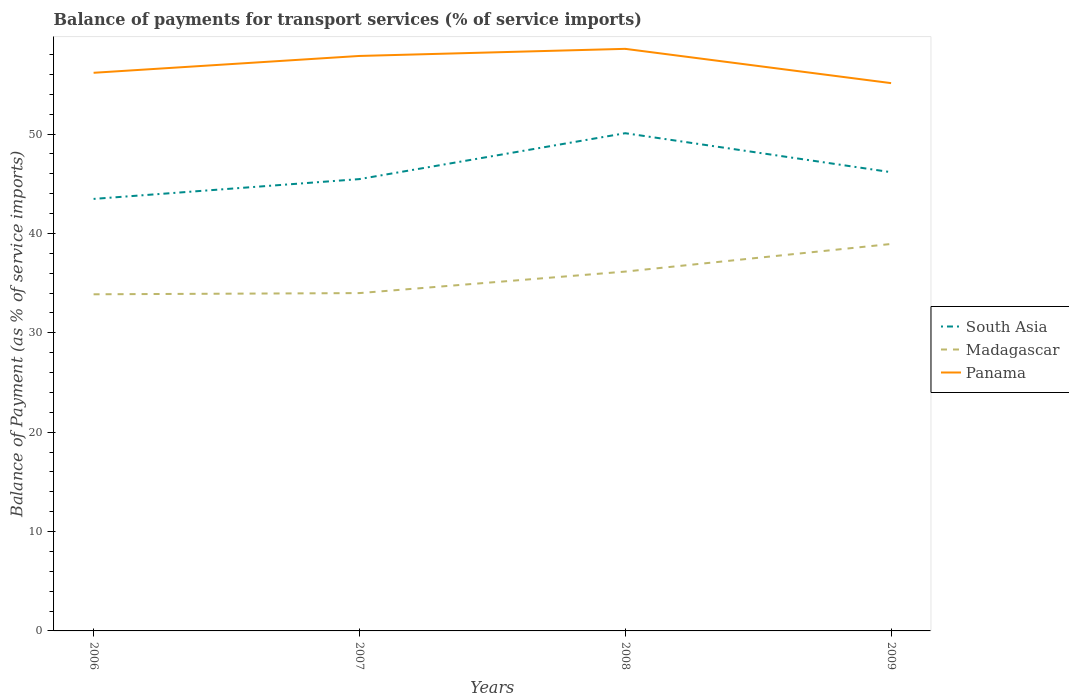Across all years, what is the maximum balance of payments for transport services in Panama?
Your response must be concise. 55.13. In which year was the balance of payments for transport services in Panama maximum?
Provide a short and direct response. 2009. What is the total balance of payments for transport services in Panama in the graph?
Provide a succinct answer. -0.71. What is the difference between the highest and the second highest balance of payments for transport services in Panama?
Your answer should be very brief. 3.45. What is the difference between the highest and the lowest balance of payments for transport services in Panama?
Provide a short and direct response. 2. Is the balance of payments for transport services in South Asia strictly greater than the balance of payments for transport services in Madagascar over the years?
Your response must be concise. No. How many lines are there?
Your answer should be very brief. 3. How many years are there in the graph?
Your response must be concise. 4. Are the values on the major ticks of Y-axis written in scientific E-notation?
Give a very brief answer. No. Does the graph contain grids?
Your answer should be compact. No. How are the legend labels stacked?
Provide a short and direct response. Vertical. What is the title of the graph?
Provide a short and direct response. Balance of payments for transport services (% of service imports). What is the label or title of the Y-axis?
Provide a succinct answer. Balance of Payment (as % of service imports). What is the Balance of Payment (as % of service imports) in South Asia in 2006?
Give a very brief answer. 43.48. What is the Balance of Payment (as % of service imports) in Madagascar in 2006?
Offer a terse response. 33.88. What is the Balance of Payment (as % of service imports) of Panama in 2006?
Your answer should be very brief. 56.17. What is the Balance of Payment (as % of service imports) in South Asia in 2007?
Your answer should be compact. 45.47. What is the Balance of Payment (as % of service imports) of Madagascar in 2007?
Give a very brief answer. 34. What is the Balance of Payment (as % of service imports) in Panama in 2007?
Offer a terse response. 57.86. What is the Balance of Payment (as % of service imports) of South Asia in 2008?
Offer a very short reply. 50.09. What is the Balance of Payment (as % of service imports) of Madagascar in 2008?
Ensure brevity in your answer.  36.16. What is the Balance of Payment (as % of service imports) in Panama in 2008?
Offer a very short reply. 58.58. What is the Balance of Payment (as % of service imports) of South Asia in 2009?
Keep it short and to the point. 46.17. What is the Balance of Payment (as % of service imports) of Madagascar in 2009?
Provide a short and direct response. 38.94. What is the Balance of Payment (as % of service imports) in Panama in 2009?
Provide a succinct answer. 55.13. Across all years, what is the maximum Balance of Payment (as % of service imports) in South Asia?
Make the answer very short. 50.09. Across all years, what is the maximum Balance of Payment (as % of service imports) in Madagascar?
Give a very brief answer. 38.94. Across all years, what is the maximum Balance of Payment (as % of service imports) of Panama?
Give a very brief answer. 58.58. Across all years, what is the minimum Balance of Payment (as % of service imports) of South Asia?
Provide a succinct answer. 43.48. Across all years, what is the minimum Balance of Payment (as % of service imports) of Madagascar?
Your answer should be compact. 33.88. Across all years, what is the minimum Balance of Payment (as % of service imports) of Panama?
Your answer should be very brief. 55.13. What is the total Balance of Payment (as % of service imports) of South Asia in the graph?
Make the answer very short. 185.2. What is the total Balance of Payment (as % of service imports) in Madagascar in the graph?
Give a very brief answer. 142.98. What is the total Balance of Payment (as % of service imports) of Panama in the graph?
Offer a very short reply. 227.74. What is the difference between the Balance of Payment (as % of service imports) in South Asia in 2006 and that in 2007?
Keep it short and to the point. -2. What is the difference between the Balance of Payment (as % of service imports) in Madagascar in 2006 and that in 2007?
Give a very brief answer. -0.12. What is the difference between the Balance of Payment (as % of service imports) in Panama in 2006 and that in 2007?
Provide a short and direct response. -1.7. What is the difference between the Balance of Payment (as % of service imports) of South Asia in 2006 and that in 2008?
Your answer should be very brief. -6.61. What is the difference between the Balance of Payment (as % of service imports) of Madagascar in 2006 and that in 2008?
Your response must be concise. -2.28. What is the difference between the Balance of Payment (as % of service imports) in Panama in 2006 and that in 2008?
Your response must be concise. -2.41. What is the difference between the Balance of Payment (as % of service imports) in South Asia in 2006 and that in 2009?
Ensure brevity in your answer.  -2.69. What is the difference between the Balance of Payment (as % of service imports) of Madagascar in 2006 and that in 2009?
Your response must be concise. -5.06. What is the difference between the Balance of Payment (as % of service imports) in Panama in 2006 and that in 2009?
Your answer should be very brief. 1.04. What is the difference between the Balance of Payment (as % of service imports) in South Asia in 2007 and that in 2008?
Your answer should be compact. -4.62. What is the difference between the Balance of Payment (as % of service imports) of Madagascar in 2007 and that in 2008?
Ensure brevity in your answer.  -2.16. What is the difference between the Balance of Payment (as % of service imports) of Panama in 2007 and that in 2008?
Give a very brief answer. -0.71. What is the difference between the Balance of Payment (as % of service imports) of South Asia in 2007 and that in 2009?
Ensure brevity in your answer.  -0.69. What is the difference between the Balance of Payment (as % of service imports) in Madagascar in 2007 and that in 2009?
Keep it short and to the point. -4.94. What is the difference between the Balance of Payment (as % of service imports) of Panama in 2007 and that in 2009?
Make the answer very short. 2.74. What is the difference between the Balance of Payment (as % of service imports) in South Asia in 2008 and that in 2009?
Offer a terse response. 3.92. What is the difference between the Balance of Payment (as % of service imports) in Madagascar in 2008 and that in 2009?
Give a very brief answer. -2.78. What is the difference between the Balance of Payment (as % of service imports) of Panama in 2008 and that in 2009?
Your answer should be compact. 3.45. What is the difference between the Balance of Payment (as % of service imports) of South Asia in 2006 and the Balance of Payment (as % of service imports) of Madagascar in 2007?
Make the answer very short. 9.48. What is the difference between the Balance of Payment (as % of service imports) of South Asia in 2006 and the Balance of Payment (as % of service imports) of Panama in 2007?
Your answer should be compact. -14.39. What is the difference between the Balance of Payment (as % of service imports) of Madagascar in 2006 and the Balance of Payment (as % of service imports) of Panama in 2007?
Give a very brief answer. -23.99. What is the difference between the Balance of Payment (as % of service imports) in South Asia in 2006 and the Balance of Payment (as % of service imports) in Madagascar in 2008?
Provide a succinct answer. 7.31. What is the difference between the Balance of Payment (as % of service imports) of South Asia in 2006 and the Balance of Payment (as % of service imports) of Panama in 2008?
Make the answer very short. -15.1. What is the difference between the Balance of Payment (as % of service imports) of Madagascar in 2006 and the Balance of Payment (as % of service imports) of Panama in 2008?
Your response must be concise. -24.7. What is the difference between the Balance of Payment (as % of service imports) in South Asia in 2006 and the Balance of Payment (as % of service imports) in Madagascar in 2009?
Make the answer very short. 4.53. What is the difference between the Balance of Payment (as % of service imports) in South Asia in 2006 and the Balance of Payment (as % of service imports) in Panama in 2009?
Ensure brevity in your answer.  -11.65. What is the difference between the Balance of Payment (as % of service imports) in Madagascar in 2006 and the Balance of Payment (as % of service imports) in Panama in 2009?
Provide a succinct answer. -21.25. What is the difference between the Balance of Payment (as % of service imports) in South Asia in 2007 and the Balance of Payment (as % of service imports) in Madagascar in 2008?
Keep it short and to the point. 9.31. What is the difference between the Balance of Payment (as % of service imports) of South Asia in 2007 and the Balance of Payment (as % of service imports) of Panama in 2008?
Ensure brevity in your answer.  -13.11. What is the difference between the Balance of Payment (as % of service imports) of Madagascar in 2007 and the Balance of Payment (as % of service imports) of Panama in 2008?
Your answer should be very brief. -24.58. What is the difference between the Balance of Payment (as % of service imports) in South Asia in 2007 and the Balance of Payment (as % of service imports) in Madagascar in 2009?
Ensure brevity in your answer.  6.53. What is the difference between the Balance of Payment (as % of service imports) of South Asia in 2007 and the Balance of Payment (as % of service imports) of Panama in 2009?
Your response must be concise. -9.66. What is the difference between the Balance of Payment (as % of service imports) in Madagascar in 2007 and the Balance of Payment (as % of service imports) in Panama in 2009?
Your answer should be compact. -21.13. What is the difference between the Balance of Payment (as % of service imports) of South Asia in 2008 and the Balance of Payment (as % of service imports) of Madagascar in 2009?
Your response must be concise. 11.15. What is the difference between the Balance of Payment (as % of service imports) of South Asia in 2008 and the Balance of Payment (as % of service imports) of Panama in 2009?
Provide a succinct answer. -5.04. What is the difference between the Balance of Payment (as % of service imports) in Madagascar in 2008 and the Balance of Payment (as % of service imports) in Panama in 2009?
Your response must be concise. -18.97. What is the average Balance of Payment (as % of service imports) in South Asia per year?
Offer a terse response. 46.3. What is the average Balance of Payment (as % of service imports) in Madagascar per year?
Provide a succinct answer. 35.75. What is the average Balance of Payment (as % of service imports) of Panama per year?
Your answer should be compact. 56.94. In the year 2006, what is the difference between the Balance of Payment (as % of service imports) in South Asia and Balance of Payment (as % of service imports) in Madagascar?
Provide a short and direct response. 9.6. In the year 2006, what is the difference between the Balance of Payment (as % of service imports) in South Asia and Balance of Payment (as % of service imports) in Panama?
Make the answer very short. -12.69. In the year 2006, what is the difference between the Balance of Payment (as % of service imports) of Madagascar and Balance of Payment (as % of service imports) of Panama?
Your answer should be compact. -22.29. In the year 2007, what is the difference between the Balance of Payment (as % of service imports) of South Asia and Balance of Payment (as % of service imports) of Madagascar?
Your answer should be compact. 11.47. In the year 2007, what is the difference between the Balance of Payment (as % of service imports) of South Asia and Balance of Payment (as % of service imports) of Panama?
Ensure brevity in your answer.  -12.39. In the year 2007, what is the difference between the Balance of Payment (as % of service imports) of Madagascar and Balance of Payment (as % of service imports) of Panama?
Provide a short and direct response. -23.87. In the year 2008, what is the difference between the Balance of Payment (as % of service imports) in South Asia and Balance of Payment (as % of service imports) in Madagascar?
Make the answer very short. 13.93. In the year 2008, what is the difference between the Balance of Payment (as % of service imports) of South Asia and Balance of Payment (as % of service imports) of Panama?
Give a very brief answer. -8.49. In the year 2008, what is the difference between the Balance of Payment (as % of service imports) in Madagascar and Balance of Payment (as % of service imports) in Panama?
Your answer should be compact. -22.42. In the year 2009, what is the difference between the Balance of Payment (as % of service imports) in South Asia and Balance of Payment (as % of service imports) in Madagascar?
Ensure brevity in your answer.  7.22. In the year 2009, what is the difference between the Balance of Payment (as % of service imports) of South Asia and Balance of Payment (as % of service imports) of Panama?
Your response must be concise. -8.96. In the year 2009, what is the difference between the Balance of Payment (as % of service imports) of Madagascar and Balance of Payment (as % of service imports) of Panama?
Ensure brevity in your answer.  -16.19. What is the ratio of the Balance of Payment (as % of service imports) in South Asia in 2006 to that in 2007?
Provide a succinct answer. 0.96. What is the ratio of the Balance of Payment (as % of service imports) in Panama in 2006 to that in 2007?
Offer a terse response. 0.97. What is the ratio of the Balance of Payment (as % of service imports) in South Asia in 2006 to that in 2008?
Provide a short and direct response. 0.87. What is the ratio of the Balance of Payment (as % of service imports) in Madagascar in 2006 to that in 2008?
Provide a succinct answer. 0.94. What is the ratio of the Balance of Payment (as % of service imports) in Panama in 2006 to that in 2008?
Make the answer very short. 0.96. What is the ratio of the Balance of Payment (as % of service imports) of South Asia in 2006 to that in 2009?
Make the answer very short. 0.94. What is the ratio of the Balance of Payment (as % of service imports) of Madagascar in 2006 to that in 2009?
Ensure brevity in your answer.  0.87. What is the ratio of the Balance of Payment (as % of service imports) of Panama in 2006 to that in 2009?
Your response must be concise. 1.02. What is the ratio of the Balance of Payment (as % of service imports) of South Asia in 2007 to that in 2008?
Make the answer very short. 0.91. What is the ratio of the Balance of Payment (as % of service imports) in Madagascar in 2007 to that in 2008?
Your answer should be compact. 0.94. What is the ratio of the Balance of Payment (as % of service imports) of South Asia in 2007 to that in 2009?
Your response must be concise. 0.98. What is the ratio of the Balance of Payment (as % of service imports) of Madagascar in 2007 to that in 2009?
Provide a short and direct response. 0.87. What is the ratio of the Balance of Payment (as % of service imports) in Panama in 2007 to that in 2009?
Provide a succinct answer. 1.05. What is the ratio of the Balance of Payment (as % of service imports) in South Asia in 2008 to that in 2009?
Give a very brief answer. 1.08. What is the ratio of the Balance of Payment (as % of service imports) of Panama in 2008 to that in 2009?
Your response must be concise. 1.06. What is the difference between the highest and the second highest Balance of Payment (as % of service imports) in South Asia?
Your response must be concise. 3.92. What is the difference between the highest and the second highest Balance of Payment (as % of service imports) of Madagascar?
Your answer should be compact. 2.78. What is the difference between the highest and the second highest Balance of Payment (as % of service imports) in Panama?
Offer a terse response. 0.71. What is the difference between the highest and the lowest Balance of Payment (as % of service imports) in South Asia?
Provide a short and direct response. 6.61. What is the difference between the highest and the lowest Balance of Payment (as % of service imports) of Madagascar?
Offer a very short reply. 5.06. What is the difference between the highest and the lowest Balance of Payment (as % of service imports) of Panama?
Provide a succinct answer. 3.45. 